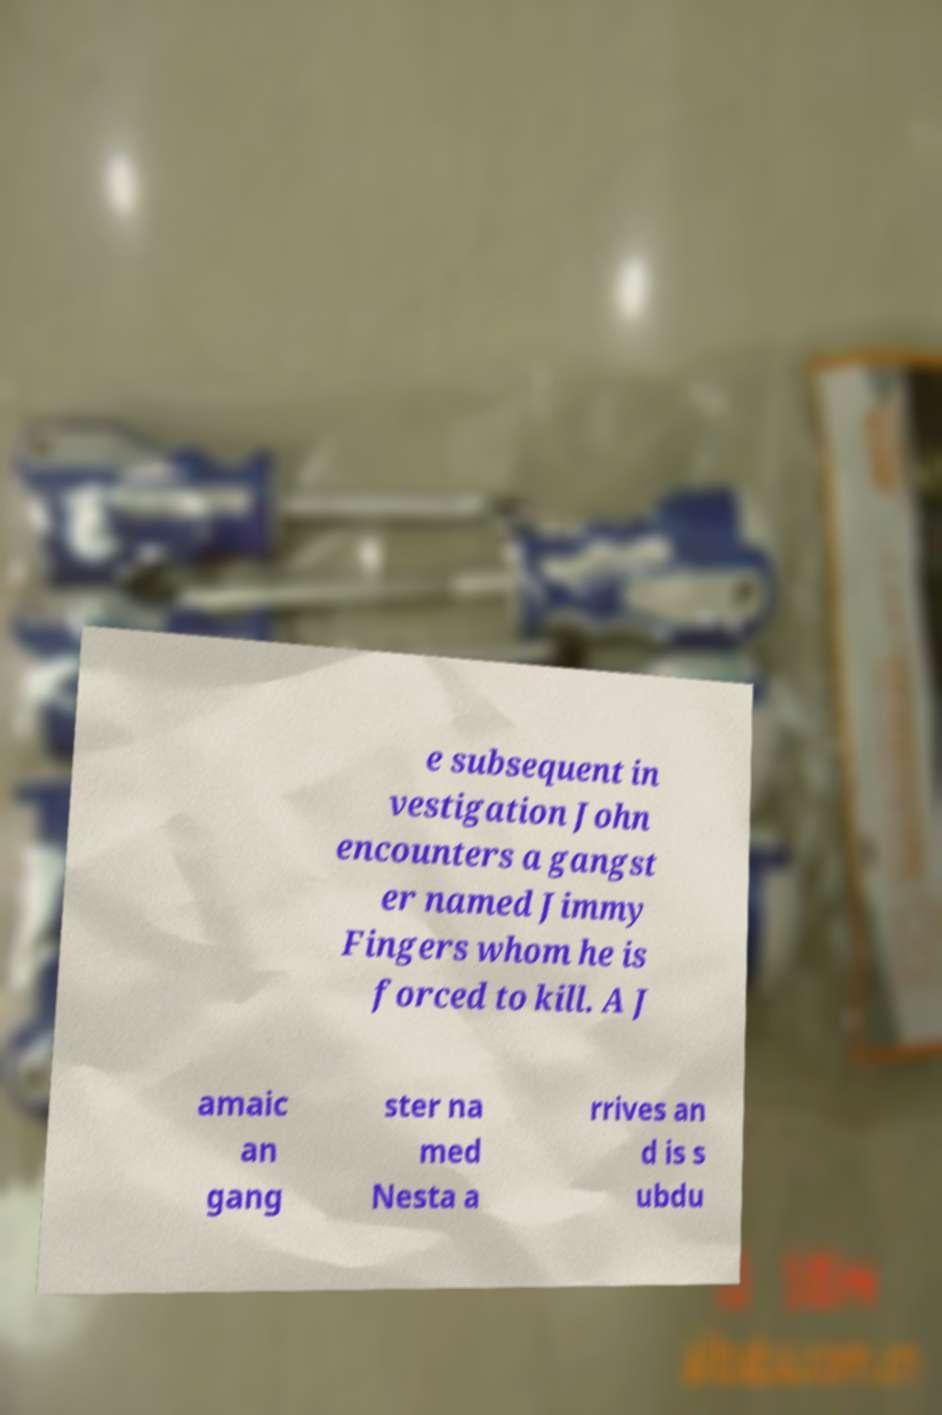Could you extract and type out the text from this image? e subsequent in vestigation John encounters a gangst er named Jimmy Fingers whom he is forced to kill. A J amaic an gang ster na med Nesta a rrives an d is s ubdu 